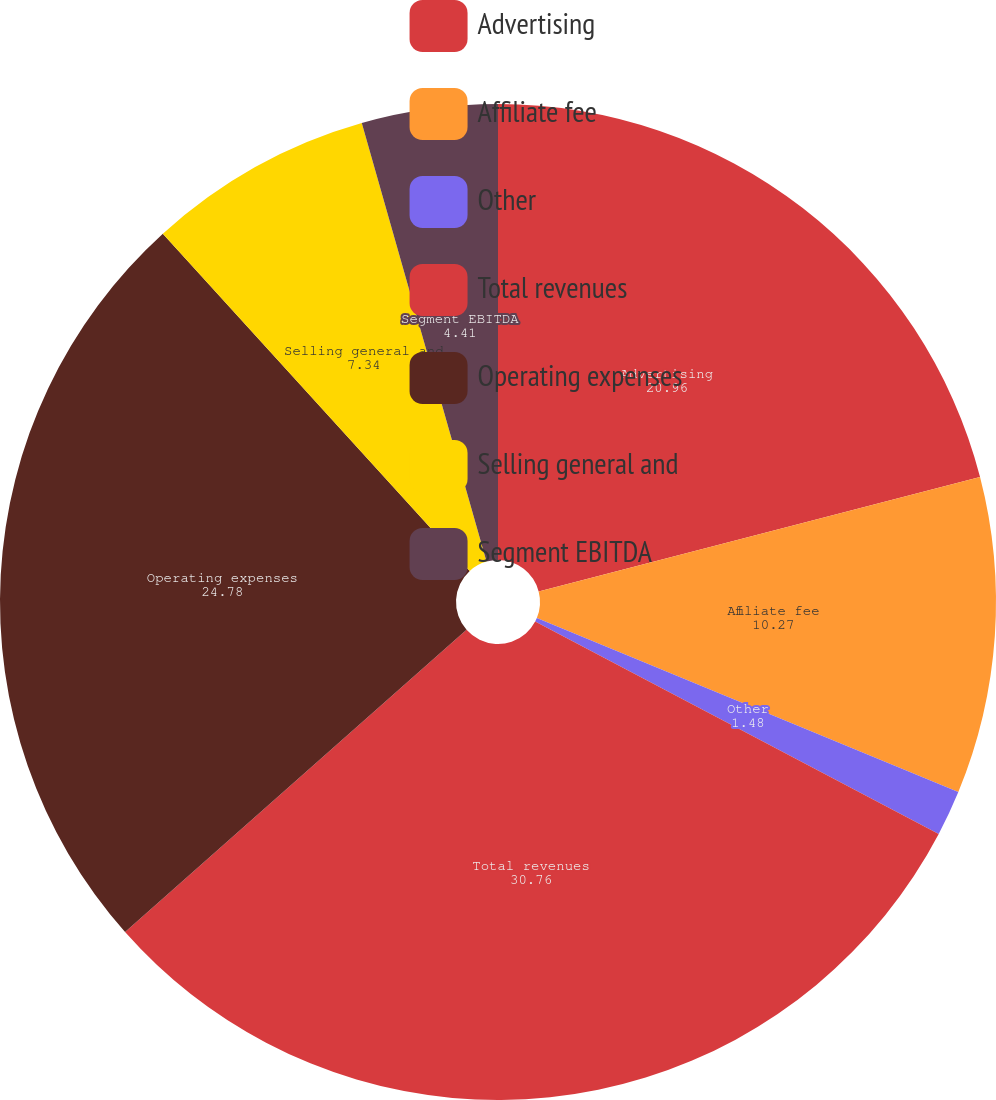Convert chart. <chart><loc_0><loc_0><loc_500><loc_500><pie_chart><fcel>Advertising<fcel>Affiliate fee<fcel>Other<fcel>Total revenues<fcel>Operating expenses<fcel>Selling general and<fcel>Segment EBITDA<nl><fcel>20.96%<fcel>10.27%<fcel>1.48%<fcel>30.76%<fcel>24.78%<fcel>7.34%<fcel>4.41%<nl></chart> 